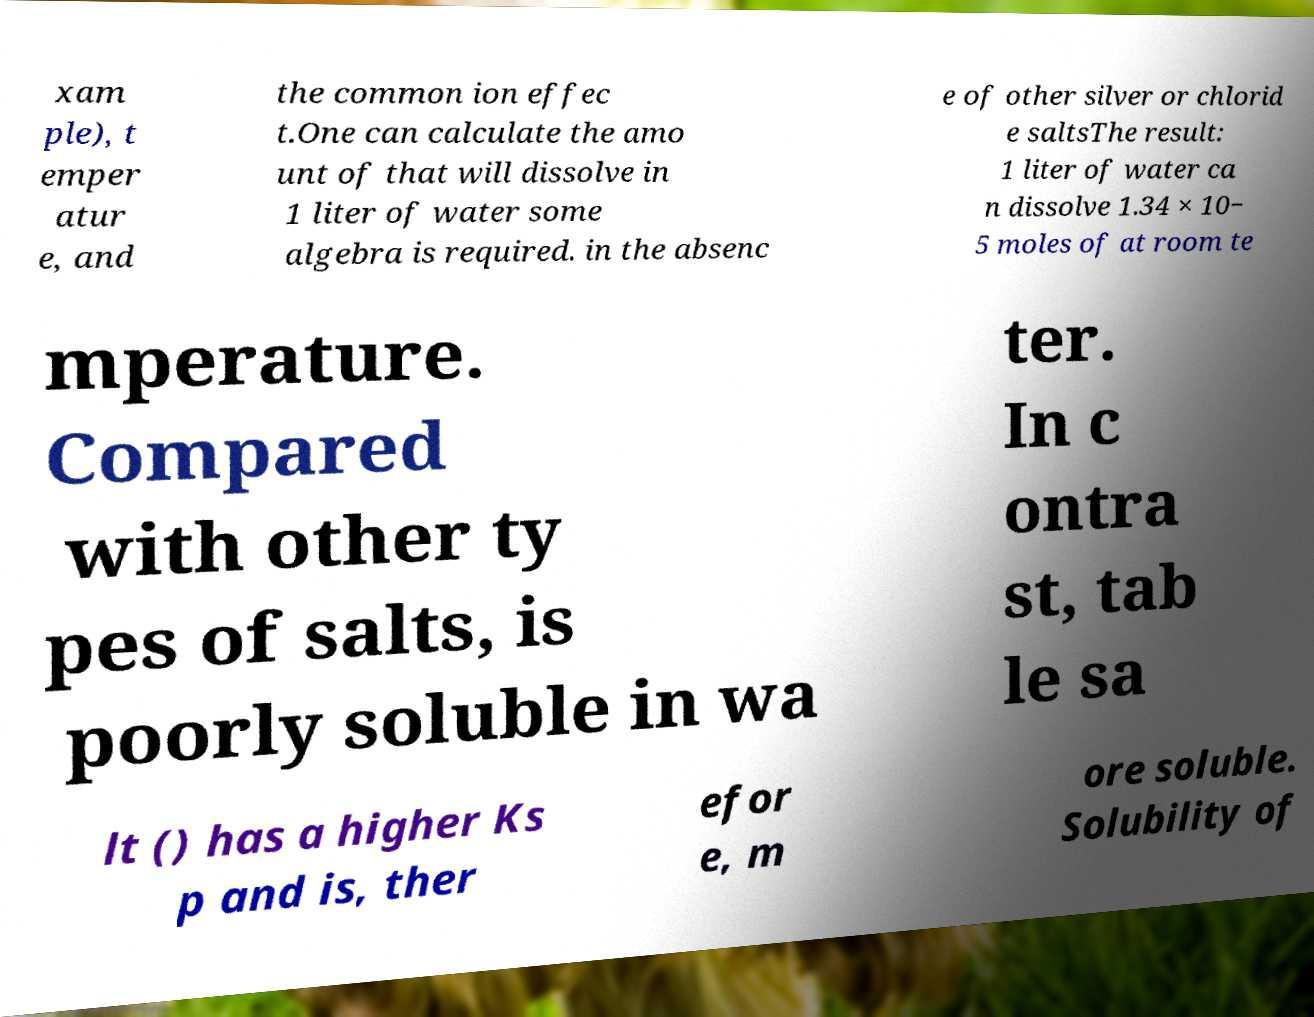Could you assist in decoding the text presented in this image and type it out clearly? xam ple), t emper atur e, and the common ion effec t.One can calculate the amo unt of that will dissolve in 1 liter of water some algebra is required. in the absenc e of other silver or chlorid e saltsThe result: 1 liter of water ca n dissolve 1.34 × 10− 5 moles of at room te mperature. Compared with other ty pes of salts, is poorly soluble in wa ter. In c ontra st, tab le sa lt () has a higher Ks p and is, ther efor e, m ore soluble. Solubility of 